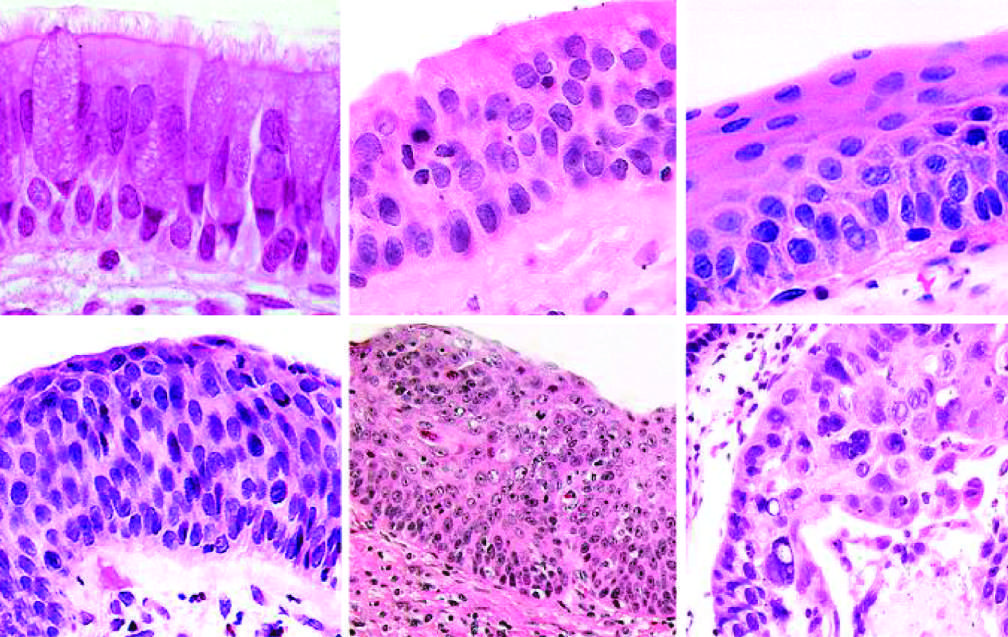do the midface structures include the appearance of squamous dysplasia, characterized by the presence of disordered squamous epithelium, with loss of nuclear polarity, nuclear hyperchromasia, pleomorphism, and mitotic figures?
Answer the question using a single word or phrase. No 